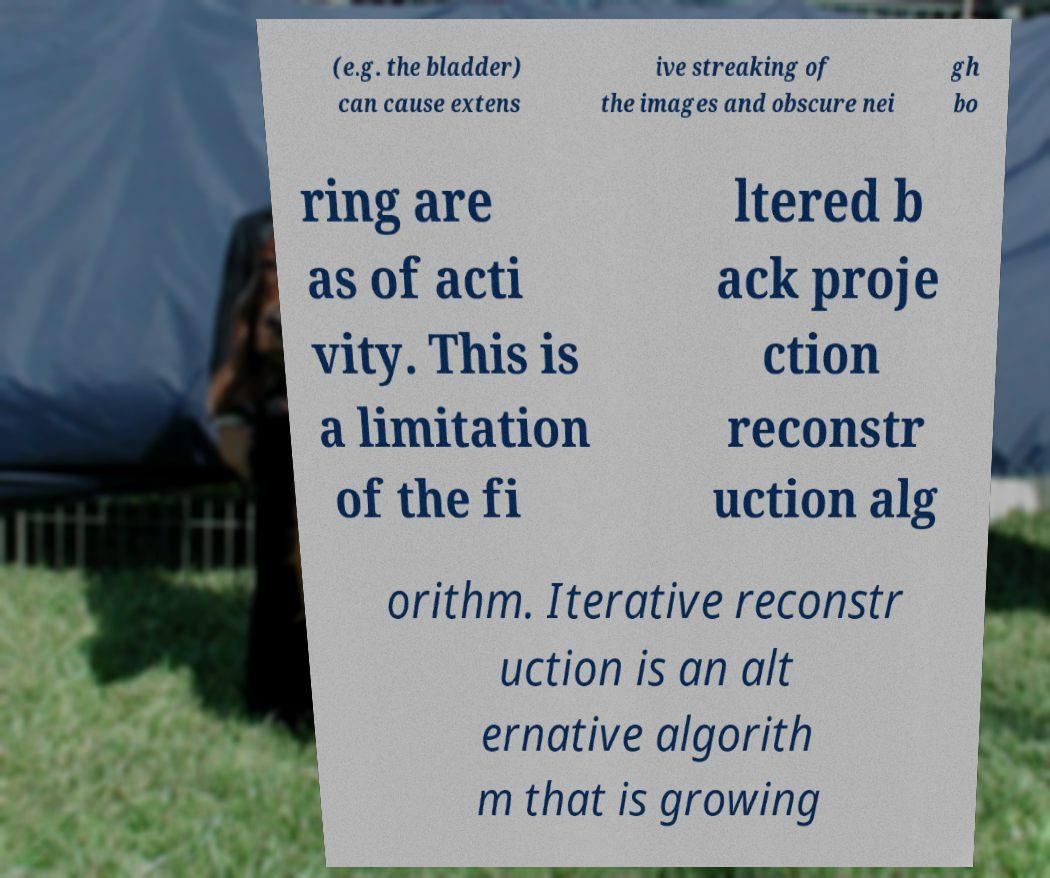Could you extract and type out the text from this image? (e.g. the bladder) can cause extens ive streaking of the images and obscure nei gh bo ring are as of acti vity. This is a limitation of the fi ltered b ack proje ction reconstr uction alg orithm. Iterative reconstr uction is an alt ernative algorith m that is growing 